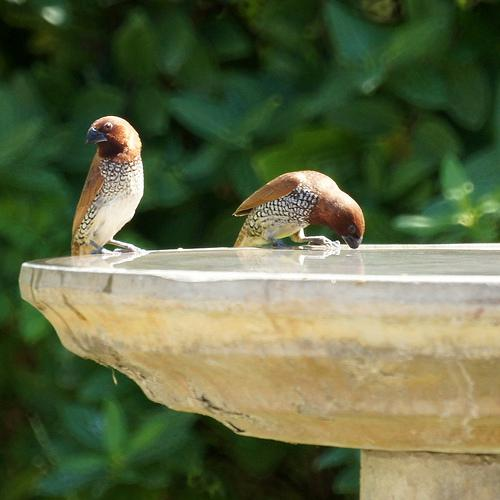Question: how is the weather?
Choices:
A. Foggy.
B. Rainy.
C. Snowing.
D. Sunny.
Answer with the letter. Answer: D Question: when was this picture taken?
Choices:
A. Nighttime.
B. Daytime.
C. Noontime.
D. Midnight.
Answer with the letter. Answer: B Question: what animals are in this picture?
Choices:
A. Squirrels.
B. Deer.
C. Bears.
D. Birds.
Answer with the letter. Answer: D Question: where was this picture taken?
Choices:
A. The bird feeder.
B. The bird house.
C. The bird bath.
D. The bird nest.
Answer with the letter. Answer: C Question: what are the birds doing?
Choices:
A. Eating bird seed.
B. Standing on perch.
C. Building a nest.
D. Drinking water.
Answer with the letter. Answer: D Question: what color are the birds?
Choices:
A. Red, blue and tan.
B. Coral, orange and taupe.
C. Teal, mauve and green.
D. Brown, black and white.
Answer with the letter. Answer: D 